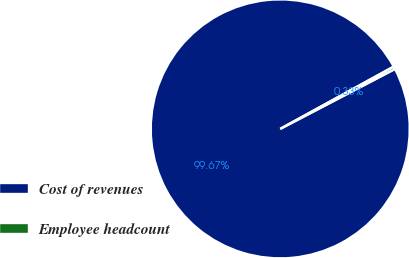<chart> <loc_0><loc_0><loc_500><loc_500><pie_chart><fcel>Cost of revenues<fcel>Employee headcount<nl><fcel>99.67%<fcel>0.33%<nl></chart> 